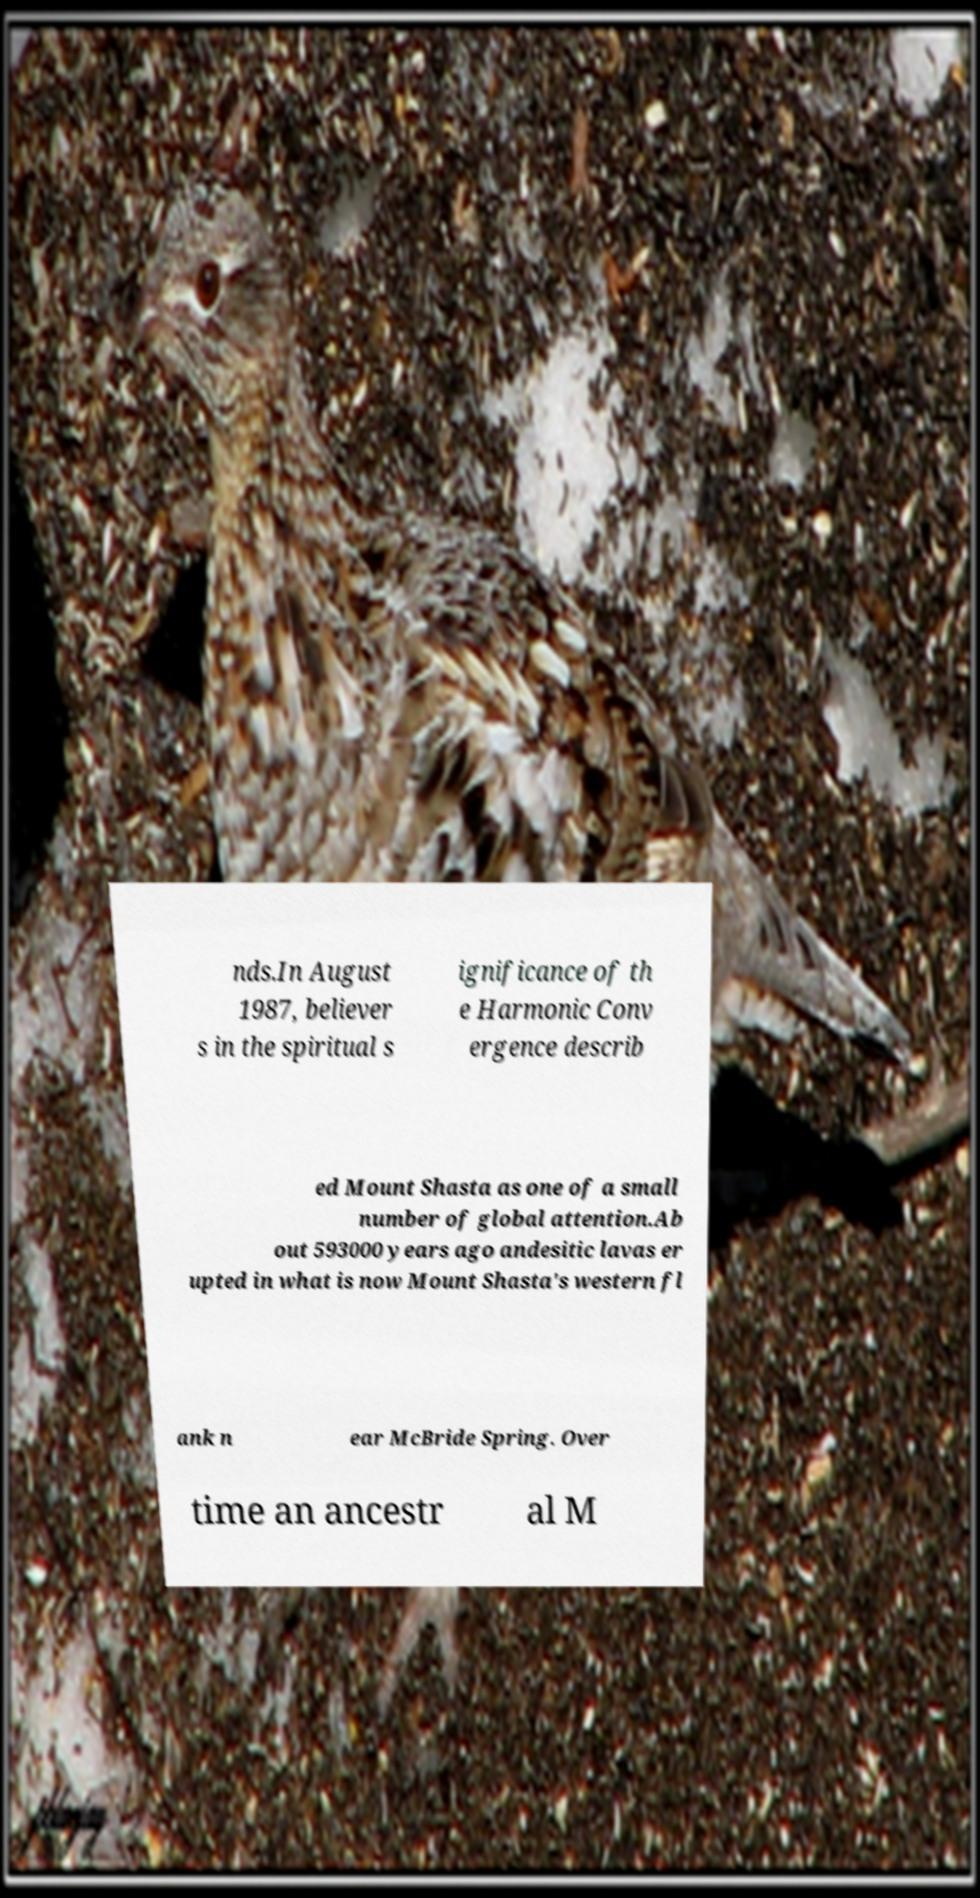Please identify and transcribe the text found in this image. nds.In August 1987, believer s in the spiritual s ignificance of th e Harmonic Conv ergence describ ed Mount Shasta as one of a small number of global attention.Ab out 593000 years ago andesitic lavas er upted in what is now Mount Shasta's western fl ank n ear McBride Spring. Over time an ancestr al M 